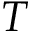Convert formula to latex. <formula><loc_0><loc_0><loc_500><loc_500>T</formula> 